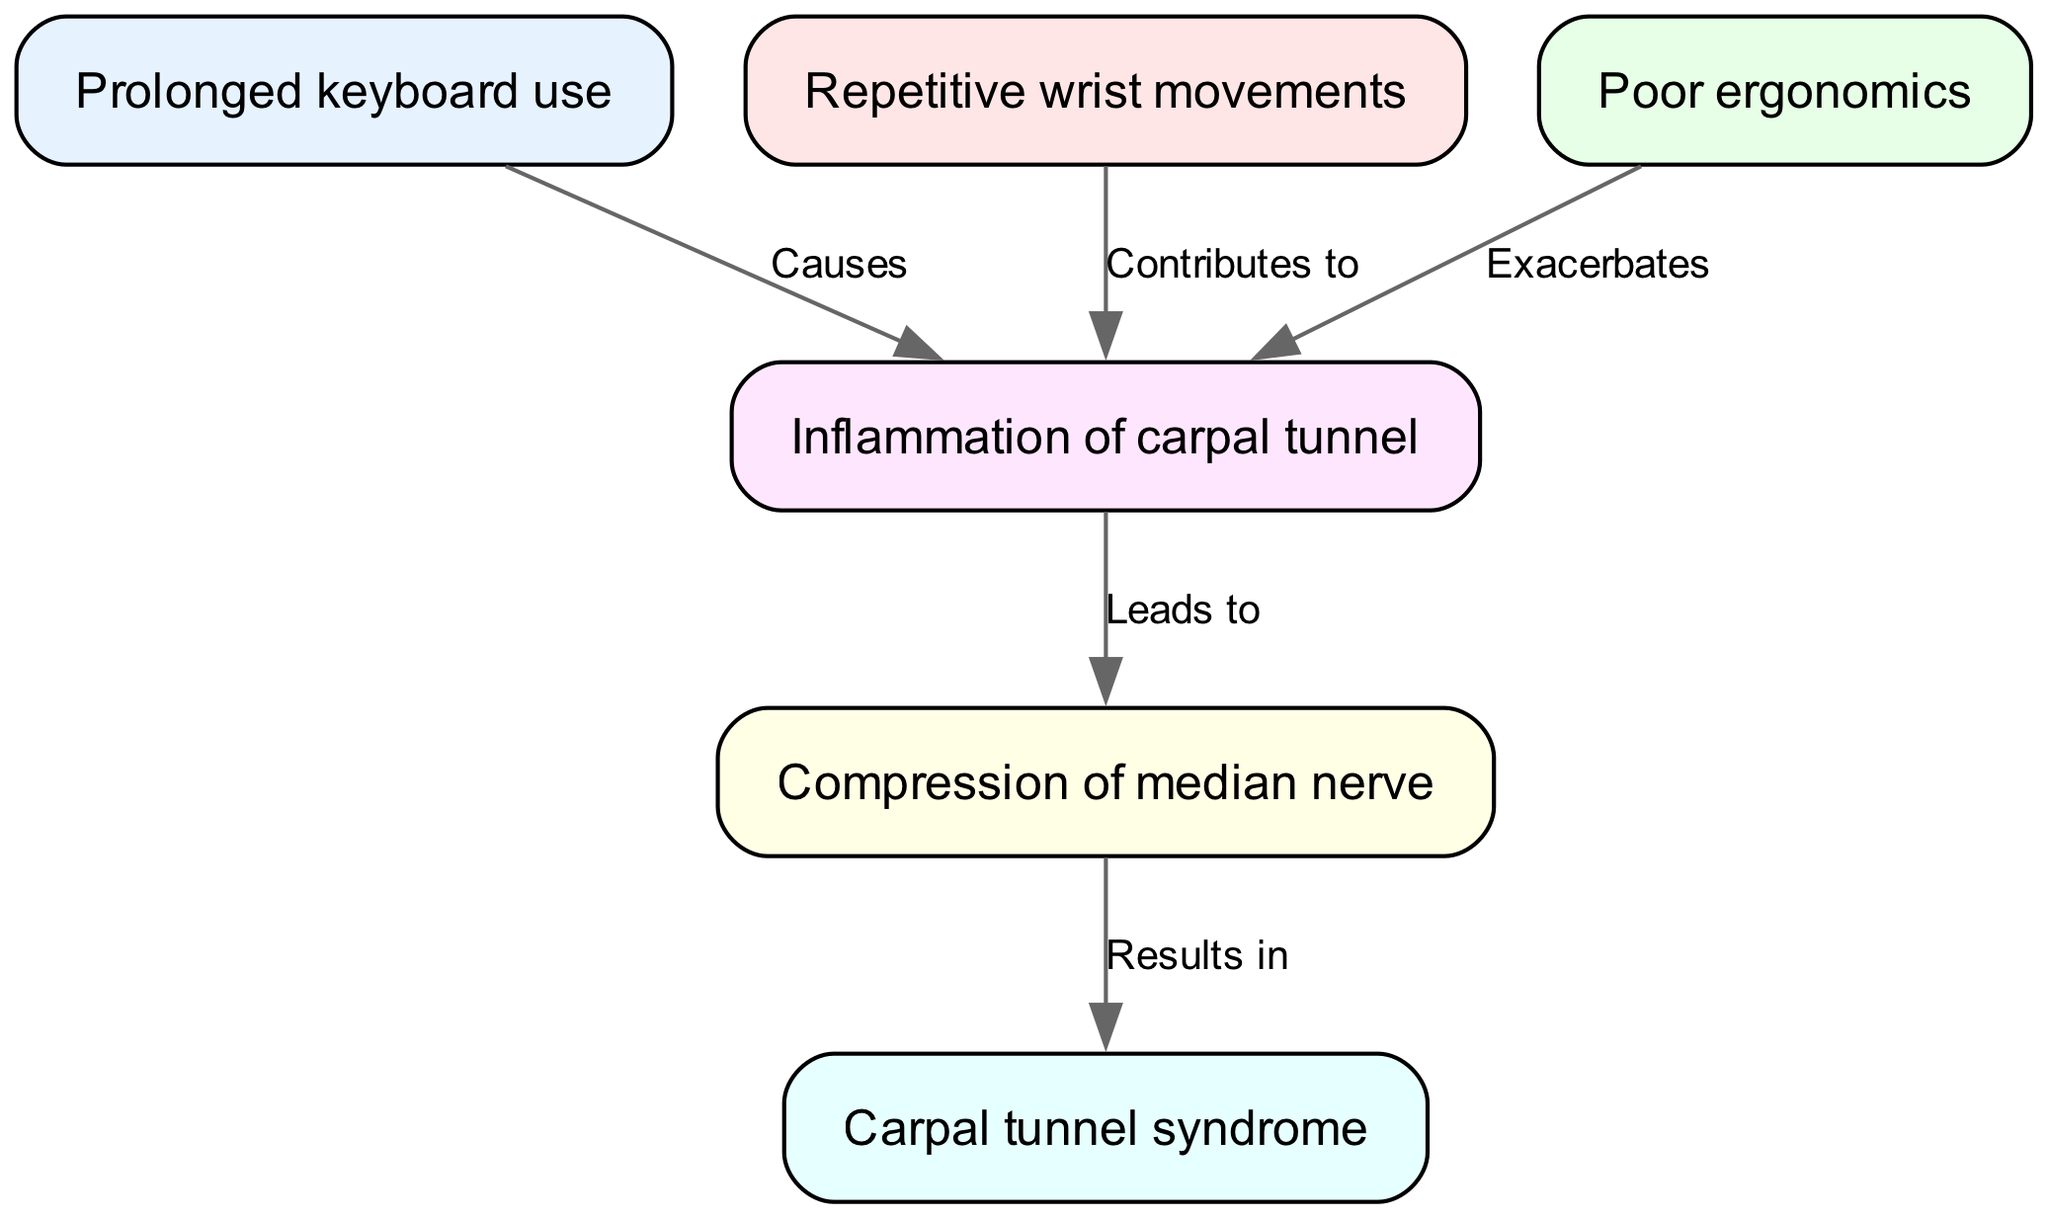What is the starting point of the flowchart? The flowchart starts with the node labeled "Prolonged keyboard use," which is the first node in the diagram.
Answer: Prolonged keyboard use How many nodes are in the diagram? By counting the entries listed in the "nodes" section of the data, there are 6 distinct nodes represented in the diagram.
Answer: 6 What leads to the inflammation of the carpal tunnel? The diagram shows that both "Prolonged keyboard use" and "Repetitive wrist movements" contribute to the inflammation of the carpal tunnel, as indicated by the "Causes" and "Contributes to" labels between the nodes.
Answer: Prolonged keyboard use, Repetitive wrist movements Which node mentions "Compression of median nerve"? The diagram contains a node labeled "Compression of median nerve," which is specifically connected to the prior node "Inflammation of carpal tunnel."
Answer: Compression of median nerve What is the final result shown in the flowchart? The diagram concludes with the node labeled "Carpal tunnel syndrome," which is noted as the outcome of the process leading from the previous nodes.
Answer: Carpal tunnel syndrome Explain how "Poor ergonomics" affects the process. In the diagram, "Poor ergonomics" is shown to exacerbate the inflammation of the carpal tunnel, as indicated by the arrow labeled "Exacerbates" pointing from "Poor ergonomics" to "Inflammation of carpal tunnel." This illustrates its negative impact on the overall condition.
Answer: Exacerbates What is the effect of "Inflammation of carpal tunnel" according to the diagram? The effect of "Inflammation of carpal tunnel" is illustrated in the diagram as it leads to "Compression of median nerve," indicating a direct consequence of the inflammation.
Answer: Leads to How does "Repetitive wrist movements" relate to carpal tunnel syndrome? "Repetitive wrist movements" are shown to contribute to the "Inflammation of carpal tunnel." In the following steps, this inflammation leads to compression of the median nerve, which ultimately results in "Carpal tunnel syndrome." Hence, it plays a crucial role in the development of the syndrome.
Answer: Contributes to What type of diagram is depicted? The diagram is a flowchart that illustrates the process of carpal tunnel syndrome development in IT professionals, outlining various contributing factors and their relationships.
Answer: Flowchart 